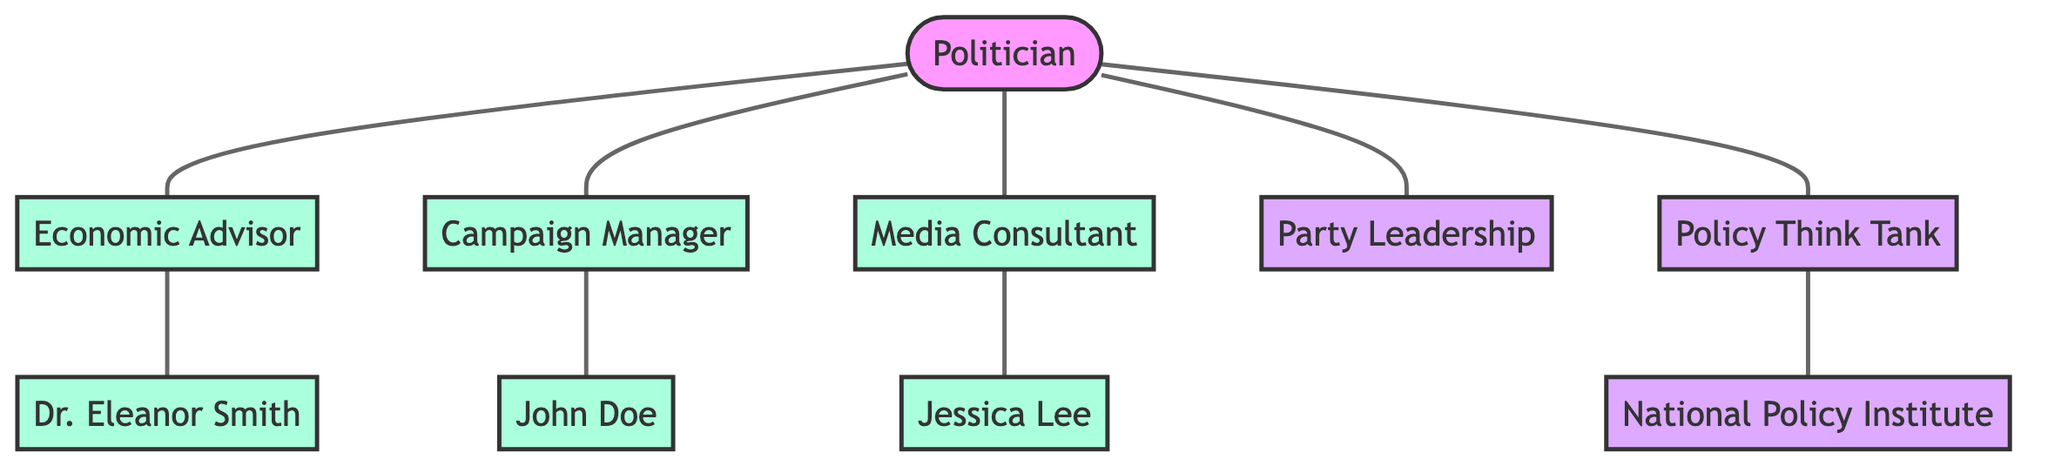What is the total number of nodes in the diagram? The diagram consists of a total of 10 nodes, which include the Politician, Economic Advisor, Dr. Eleanor Smith, Campaign Manager, John Doe, Media Consultant, Jessica Lee, Party Leadership, Policy Think Tank, and National Policy Institute.
Answer: 10 Which advisor connects to Dr. Eleanor Smith? In the diagram, the Economic Advisor is the node that has a direct connection to Dr. Eleanor Smith, indicating that the advisor influences her.
Answer: Economic Advisor How many direct advisors does the Politician have? The Politician is directly connected to 5 different advisors: Economic Advisor, Campaign Manager, Media Consultant, Party Leadership, and Policy Think Tank. By counting the connections, the answer is found.
Answer: 5 Which institution is linked to the Policy Think Tank? The National Policy Institute is directly connected to the Policy Think Tank in the diagram, signifying the relationship between them.
Answer: National Policy Institute Who is the Campaign Manager linked to? The Campaign Manager has a direct connection to John Doe, indicating that John Doe is the individual linked to the Campaign Manager.
Answer: John Doe Who is the media consultant connected to? Jessica Lee is the individual directly connected to the Media Consultant in the diagram, indicating their association.
Answer: Jessica Lee What type of graph is represented by this diagram? The diagram is characterized as an undirected graph since the connections between the nodes do not indicate a specific directionality, meaning relationships can be bi-directional.
Answer: Undirected Graph Which advisor connects the Politician with the Policy Think Tank? The connection between the Politician and Policy Think Tank is directly linked through the advisor known as the Policy Think Tank, which serves as an advisor to the politician.
Answer: Policy Think Tank What is the relationship between the Economic Advisor and Dr. Eleanor Smith? The Economic Advisor has a direct connection to Dr. Eleanor Smith, indicating that the Economic Advisor influences or works with Dr. Eleanor Smith.
Answer: Influence 